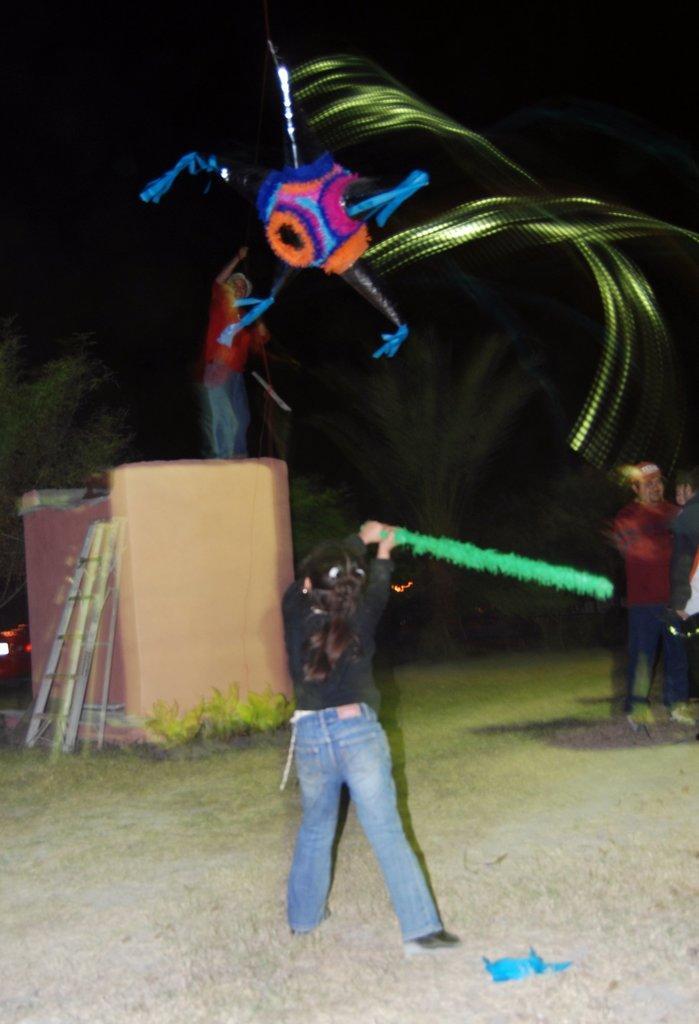Please provide a concise description of this image. There is a girl holding a stick. In the back there is a stand. Near to her there is ladder. On that a person is standing. And there is a blue, orange and a pink color thing in the air. In the background it is dark. 